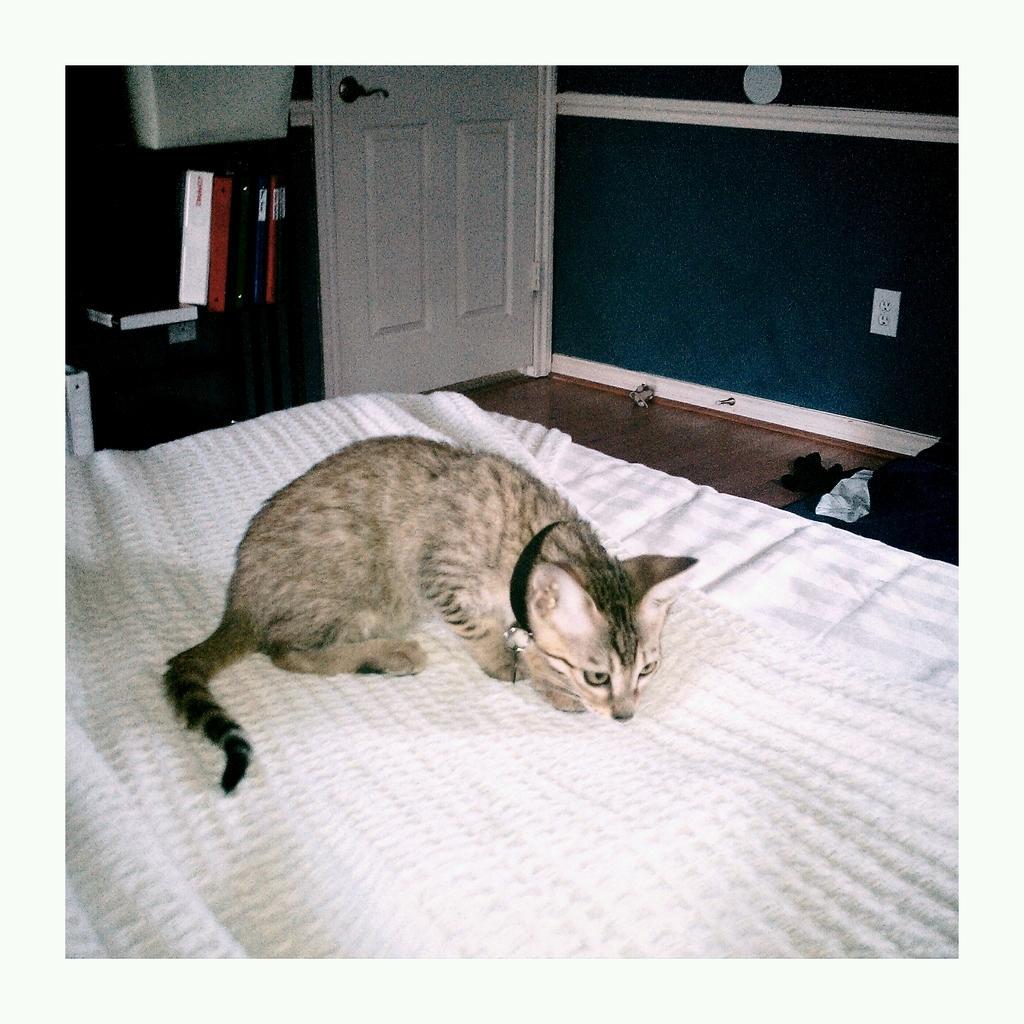Could you give a brief overview of what you see in this image? In this image I can see a cat on a bed. In the background I can see few books and a door. 